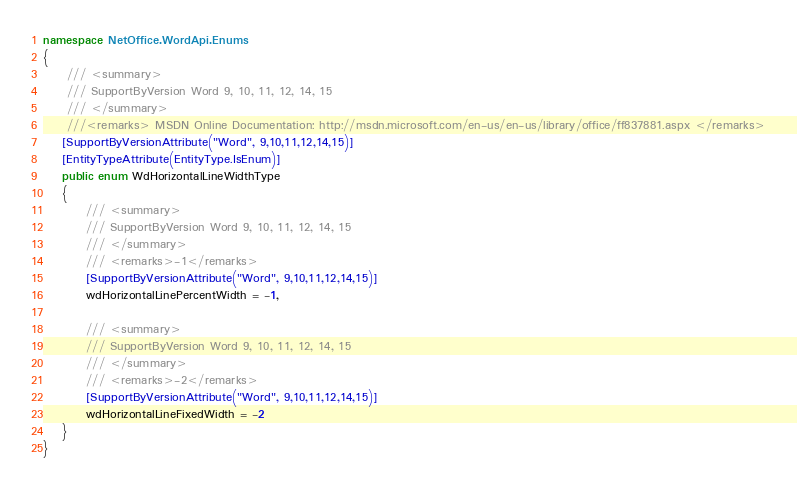Convert code to text. <code><loc_0><loc_0><loc_500><loc_500><_C#_>namespace NetOffice.WordApi.Enums
{
	 /// <summary>
	 /// SupportByVersion Word 9, 10, 11, 12, 14, 15
	 /// </summary>
	 ///<remarks> MSDN Online Documentation: http://msdn.microsoft.com/en-us/en-us/library/office/ff837881.aspx </remarks>
	[SupportByVersionAttribute("Word", 9,10,11,12,14,15)]
	[EntityTypeAttribute(EntityType.IsEnum)]
	public enum WdHorizontalLineWidthType
	{
		 /// <summary>
		 /// SupportByVersion Word 9, 10, 11, 12, 14, 15
		 /// </summary>
		 /// <remarks>-1</remarks>
		 [SupportByVersionAttribute("Word", 9,10,11,12,14,15)]
		 wdHorizontalLinePercentWidth = -1,

		 /// <summary>
		 /// SupportByVersion Word 9, 10, 11, 12, 14, 15
		 /// </summary>
		 /// <remarks>-2</remarks>
		 [SupportByVersionAttribute("Word", 9,10,11,12,14,15)]
		 wdHorizontalLineFixedWidth = -2
	}
}</code> 